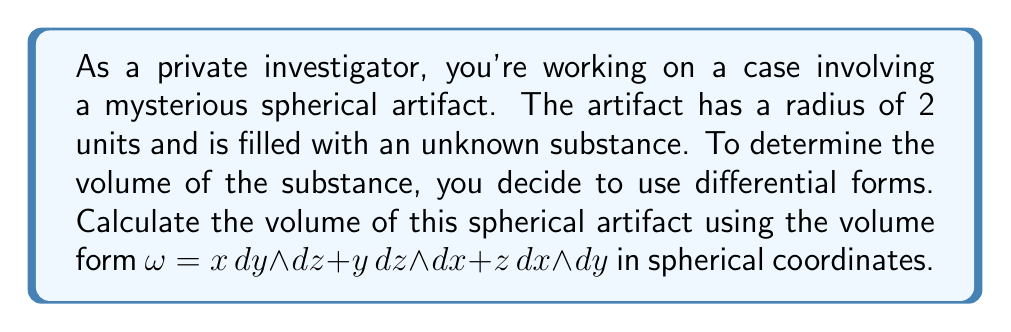Could you help me with this problem? To solve this problem, we'll follow these steps:

1) First, we need to express the volume form in spherical coordinates. The transformation from Cartesian to spherical coordinates is:

   $x = r \sin\theta \cos\phi$
   $y = r \sin\theta \sin\phi$
   $z = r \cos\theta$

2) We need to calculate the Jacobian of this transformation:

   $$J = \begin{vmatrix}
   \frac{\partial x}{\partial r} & \frac{\partial x}{\partial \theta} & \frac{\partial x}{\partial \phi} \\
   \frac{\partial y}{\partial r} & \frac{\partial y}{\partial \theta} & \frac{\partial y}{\partial \phi} \\
   \frac{\partial z}{\partial r} & \frac{\partial z}{\partial \theta} & \frac{\partial z}{\partial \phi}
   \end{vmatrix} = r^2 \sin\theta$$

3) The volume form in spherical coordinates becomes:

   $\omega = r^2 \sin\theta \, dr \wedge d\theta \wedge d\phi$

4) To calculate the volume, we need to integrate this form over the sphere:

   $$V = \iiint_S \omega = \int_0^{2\pi} \int_0^{\pi} \int_0^2 r^2 \sin\theta \, dr \, d\theta \, d\phi$$

5) Let's solve this triple integral:

   $$\begin{align*}
   V &= \int_0^{2\pi} \int_0^{\pi} \int_0^2 r^2 \sin\theta \, dr \, d\theta \, d\phi \\
   &= \int_0^{2\pi} \int_0^{\pi} \left[\frac{r^3}{3}\right]_0^2 \sin\theta \, d\theta \, d\phi \\
   &= \frac{8}{3} \int_0^{2\pi} \int_0^{\pi} \sin\theta \, d\theta \, d\phi \\
   &= \frac{8}{3} \int_0^{2\pi} \left[-\cos\theta\right]_0^{\pi} \, d\phi \\
   &= \frac{8}{3} \int_0^{2\pi} 2 \, d\phi \\
   &= \frac{16}{3} \left[\phi\right]_0^{2\pi} \\
   &= \frac{16}{3} \cdot 2\pi \\
   &= \frac{32\pi}{3}
   \end{align*}$$

Thus, the volume of the spherical artifact is $\frac{32\pi}{3}$ cubic units.
Answer: $\frac{32\pi}{3}$ cubic units 